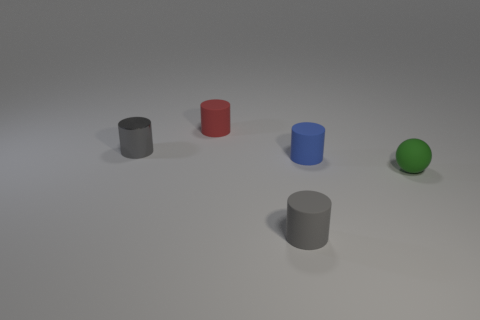What number of tiny matte cylinders are behind the tiny blue thing and in front of the small red object?
Offer a very short reply. 0. There is a green thing that is the same size as the blue rubber cylinder; what is its shape?
Provide a short and direct response. Sphere. What is the size of the blue matte cylinder?
Make the answer very short. Small. There is a small green object that is on the right side of the tiny cylinder to the right of the rubber cylinder that is in front of the tiny green rubber object; what is its material?
Make the answer very short. Rubber. There is a tiny ball that is the same material as the red cylinder; what color is it?
Offer a terse response. Green. How many shiny objects are in front of the cylinder that is behind the gray cylinder that is on the left side of the tiny red matte cylinder?
Provide a short and direct response. 1. What material is the other cylinder that is the same color as the tiny metallic cylinder?
Give a very brief answer. Rubber. Is there any other thing that has the same shape as the red matte object?
Make the answer very short. Yes. How many things are tiny matte objects that are in front of the tiny ball or small gray rubber cylinders?
Your answer should be very brief. 1. There is a rubber cylinder left of the tiny gray matte cylinder; does it have the same color as the rubber ball?
Provide a short and direct response. No. 